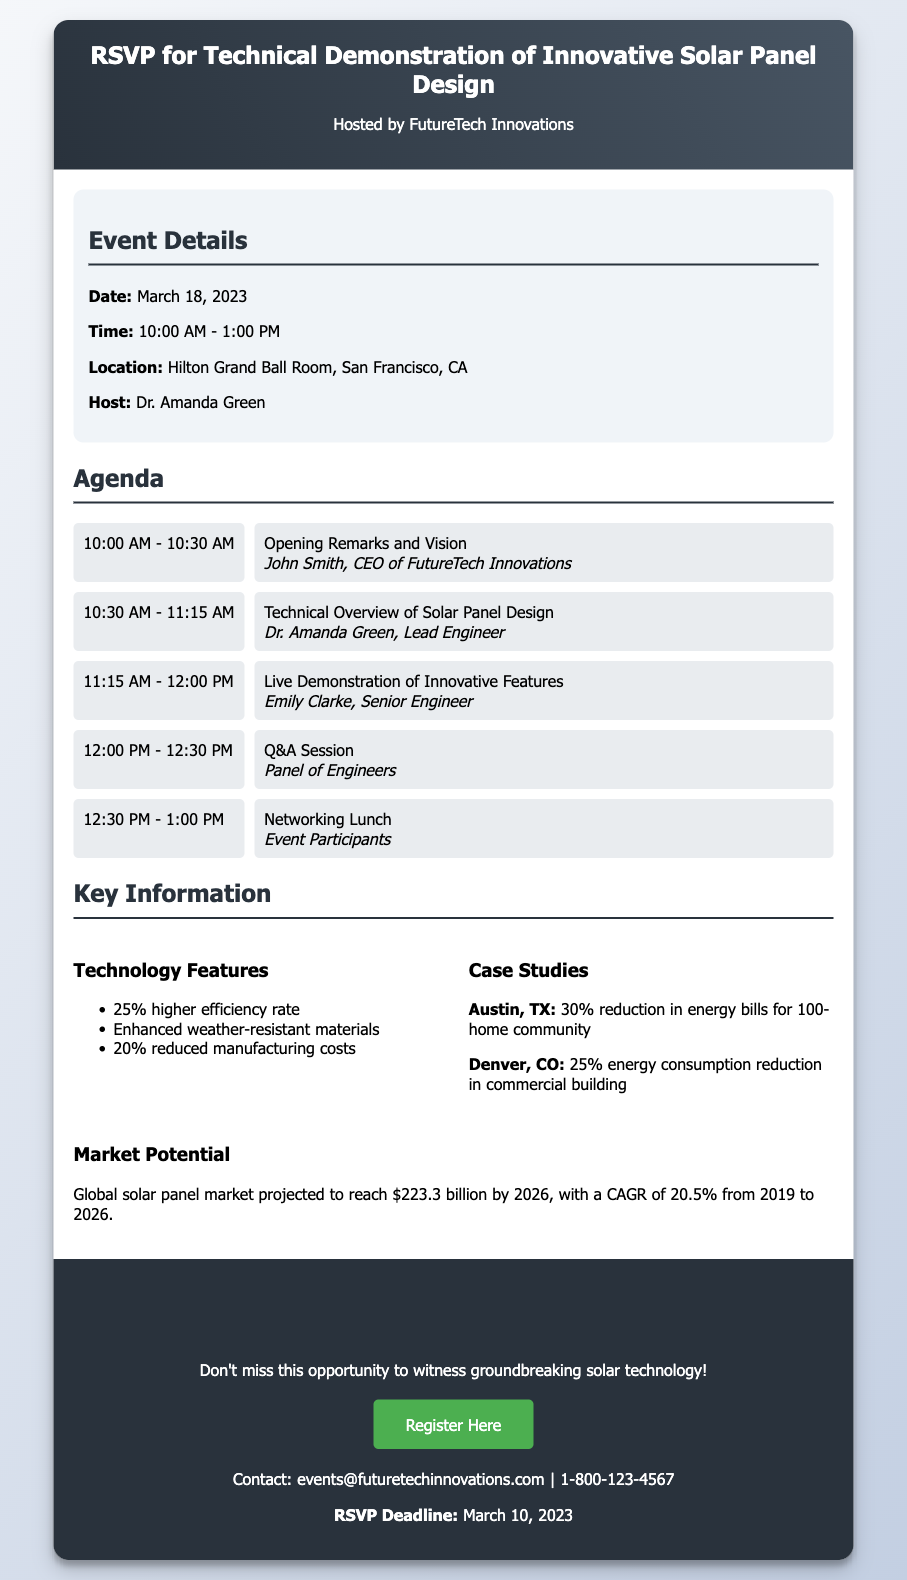What is the date of the event? The date of the event is mentioned clearly in the document.
Answer: March 18, 2023 Who is hosting the event? The document specifies the host of the event in the event details section.
Answer: Dr. Amanda Green What is one technology feature of the solar panel design? The technology features include a list of specific improvements highlighted in the key information section.
Answer: 25% higher efficiency rate What time does the Q&A session start? The agenda outlines the times for each segment of the event, including the Q&A session.
Answer: 12:00 PM What is the RSVP deadline? The RSVP deadline is stated clearly in the RSVP section of the document.
Answer: March 10, 2023 What location is the event being held at? The event location is listed in the details provided in the document.
Answer: Hilton Grand Ball Room, San Francisco, CA What is the projected growth rate of the solar panel market? The market potential provides a projected CAGR, which can be found in the key information section.
Answer: 20.5% Which keynote speaker will provide the technical overview? The agenda items list the speakers for each segment, identifying who provides the technical overview.
Answer: Dr. Amanda Green What is the contact email for the event? The contact information is included in the RSVP section of the document.
Answer: events@futuretechinnovations.com 